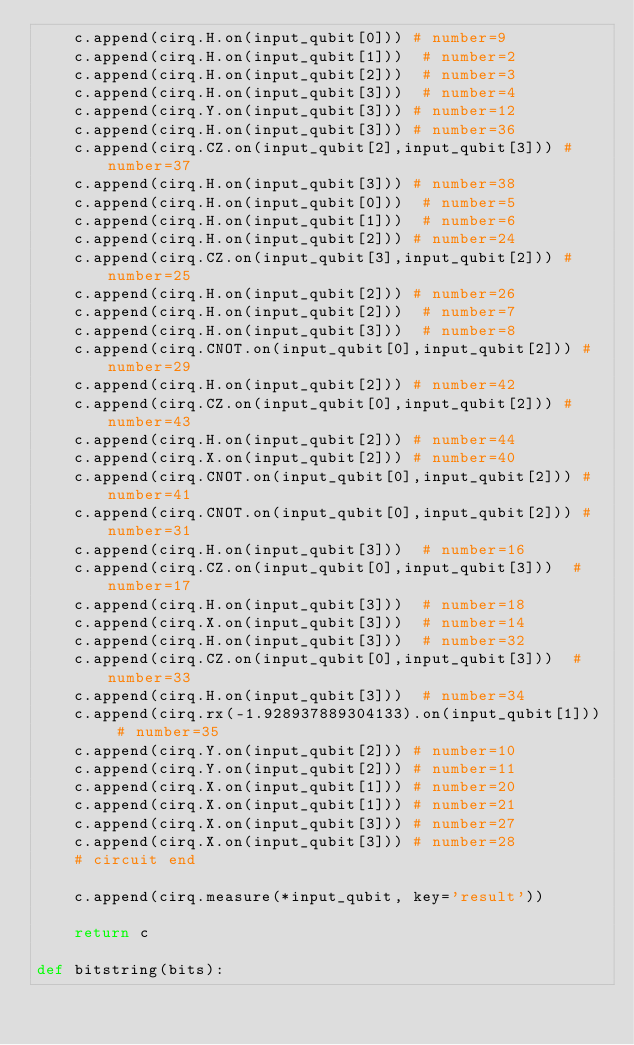Convert code to text. <code><loc_0><loc_0><loc_500><loc_500><_Python_>    c.append(cirq.H.on(input_qubit[0])) # number=9
    c.append(cirq.H.on(input_qubit[1]))  # number=2
    c.append(cirq.H.on(input_qubit[2]))  # number=3
    c.append(cirq.H.on(input_qubit[3]))  # number=4
    c.append(cirq.Y.on(input_qubit[3])) # number=12
    c.append(cirq.H.on(input_qubit[3])) # number=36
    c.append(cirq.CZ.on(input_qubit[2],input_qubit[3])) # number=37
    c.append(cirq.H.on(input_qubit[3])) # number=38
    c.append(cirq.H.on(input_qubit[0]))  # number=5
    c.append(cirq.H.on(input_qubit[1]))  # number=6
    c.append(cirq.H.on(input_qubit[2])) # number=24
    c.append(cirq.CZ.on(input_qubit[3],input_qubit[2])) # number=25
    c.append(cirq.H.on(input_qubit[2])) # number=26
    c.append(cirq.H.on(input_qubit[2]))  # number=7
    c.append(cirq.H.on(input_qubit[3]))  # number=8
    c.append(cirq.CNOT.on(input_qubit[0],input_qubit[2])) # number=29
    c.append(cirq.H.on(input_qubit[2])) # number=42
    c.append(cirq.CZ.on(input_qubit[0],input_qubit[2])) # number=43
    c.append(cirq.H.on(input_qubit[2])) # number=44
    c.append(cirq.X.on(input_qubit[2])) # number=40
    c.append(cirq.CNOT.on(input_qubit[0],input_qubit[2])) # number=41
    c.append(cirq.CNOT.on(input_qubit[0],input_qubit[2])) # number=31
    c.append(cirq.H.on(input_qubit[3]))  # number=16
    c.append(cirq.CZ.on(input_qubit[0],input_qubit[3]))  # number=17
    c.append(cirq.H.on(input_qubit[3]))  # number=18
    c.append(cirq.X.on(input_qubit[3]))  # number=14
    c.append(cirq.H.on(input_qubit[3]))  # number=32
    c.append(cirq.CZ.on(input_qubit[0],input_qubit[3]))  # number=33
    c.append(cirq.H.on(input_qubit[3]))  # number=34
    c.append(cirq.rx(-1.928937889304133).on(input_qubit[1])) # number=35
    c.append(cirq.Y.on(input_qubit[2])) # number=10
    c.append(cirq.Y.on(input_qubit[2])) # number=11
    c.append(cirq.X.on(input_qubit[1])) # number=20
    c.append(cirq.X.on(input_qubit[1])) # number=21
    c.append(cirq.X.on(input_qubit[3])) # number=27
    c.append(cirq.X.on(input_qubit[3])) # number=28
    # circuit end

    c.append(cirq.measure(*input_qubit, key='result'))

    return c

def bitstring(bits):</code> 